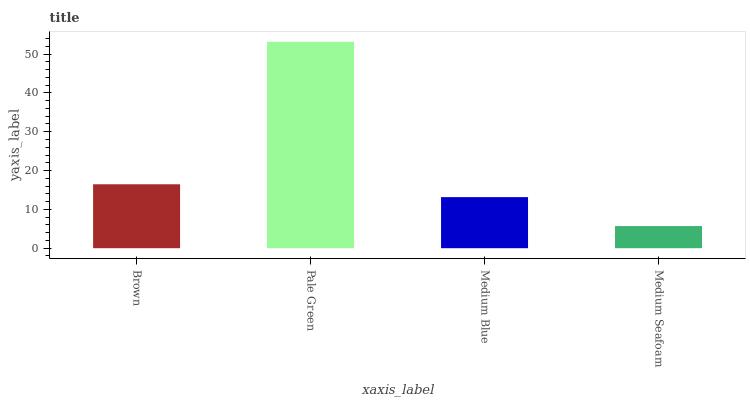Is Medium Seafoam the minimum?
Answer yes or no. Yes. Is Pale Green the maximum?
Answer yes or no. Yes. Is Medium Blue the minimum?
Answer yes or no. No. Is Medium Blue the maximum?
Answer yes or no. No. Is Pale Green greater than Medium Blue?
Answer yes or no. Yes. Is Medium Blue less than Pale Green?
Answer yes or no. Yes. Is Medium Blue greater than Pale Green?
Answer yes or no. No. Is Pale Green less than Medium Blue?
Answer yes or no. No. Is Brown the high median?
Answer yes or no. Yes. Is Medium Blue the low median?
Answer yes or no. Yes. Is Medium Blue the high median?
Answer yes or no. No. Is Pale Green the low median?
Answer yes or no. No. 